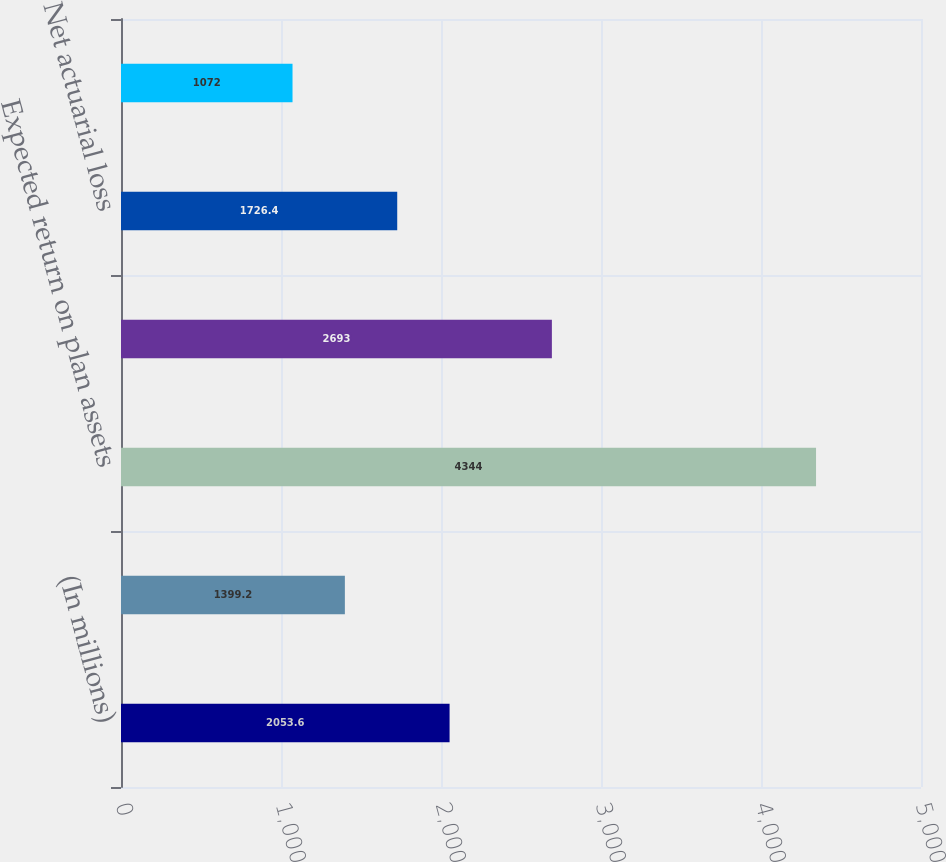Convert chart. <chart><loc_0><loc_0><loc_500><loc_500><bar_chart><fcel>(In millions)<fcel>Service cost for benefits<fcel>Expected return on plan assets<fcel>Interest cost on benefit<fcel>Net actuarial loss<fcel>Pension plans cost<nl><fcel>2053.6<fcel>1399.2<fcel>4344<fcel>2693<fcel>1726.4<fcel>1072<nl></chart> 